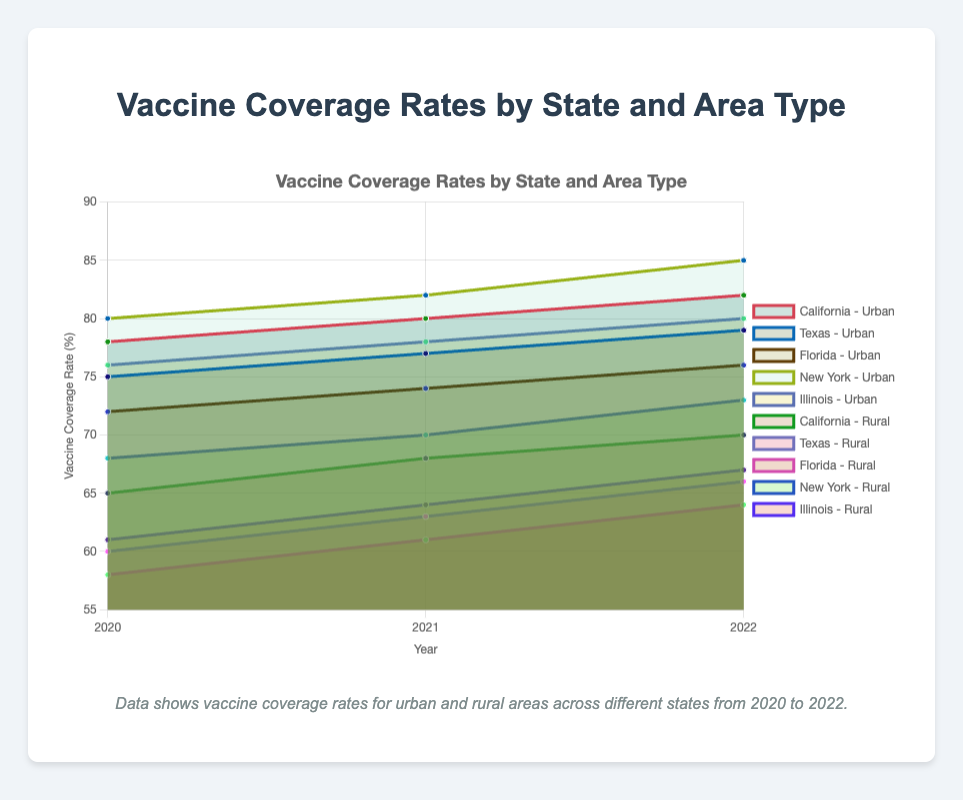What is the overall title of the chart? The title of the chart is usually prominently displayed at the top and summarizes the main topic of the chart. By looking at the top center of the chart, we can find the title "Vaccine Coverage Rates by State and Area Type".
Answer: Vaccine Coverage Rates by State and Area Type Which state had the highest urban vaccine coverage rate in 2022? To find the state with the highest urban vaccine coverage rate in 2022, look at the data points for each state in 2022 under the urban category and compare them. The state with the largest value in this category is New York with a rate of 85%.
Answer: New York How did rural vaccine coverage rates in Texas change from 2020 to 2022? Consider the specific data points for Texas under the rural category for 2020, 2021, and 2022. Rural vaccine rates in Texas were 60% in 2020, 63% in 2021, and 66% in 2022, showing a steady increase each year. Therefore, Texas saw an increase of 3 percentage points each year in rural areas.
Answer: Increased each year Which criteria can be used to classify the different sub-areas in each state in this chart? By examining the chart legend and labels, it's evident that the chart distinguishes between urban and rural areas for each state. Urban and rural categories can therefore be used as the criteria for classification.
Answer: Urban and rural What is the difference in urban vaccine coverage between New York and California in 2022? To find the difference, look at the urban coverage rates for New York and California in 2022. For New York, it is 85%, and for California, it is 82%. Subtracting California's rate from New York's rate gives 85% - 82% = 3%.
Answer: 3% Which state showed the smallest increase in urban vaccine coverage from 2020 to 2022? Look at the urban coverage rates for each state across 2020 and 2022, and calculate the increase for each. California: (82-78) = 4%, Texas: (79-75) = 4%, Florida: (76-72) = 4%, New York: (85-80) = 5%, Illinois: (80-76) = 4%. All increases are either 4% or 5%, but since the smallest increase is 4% and several states have it, an example like California shows the smallest increase.
Answer: California Is there a general trend in vaccine coverage rates between urban and rural areas? Comparing the overall vaccine rates over time for urban and rural areas visually, it is clear that urban areas consistently have higher vaccine coverage than rural areas.
Answer: Urban areas have higher rates Which state had the largest increase in rural vaccine coverage between 2020 and 2022? Calculate the rural coverage increase for each state from 2020 to 2022: California (70-65)=5%, Texas (66-60)=6%, Florida (64-58)=6%, New York (73-68)=5%, Illinois (67-61)=6%. Texas, Florida, and Illinois all had the largest increase of 6%.
Answer: Texas, Florida, or Illinois How does vaccine coverage in urban areas compare to rural areas in 2021 for Illinois? By inspecting the data points for Illinois in 2021, we see urban coverage was 78% and rural coverage was 64%. This shows urban areas had a notably higher vaccine coverage than rural areas by 14 percentage points.
Answer: 14% higher in urban areas What was the range of rural vaccine coverage rates in 2022 among all states? To determine the range, find the minimum and maximum rural vaccine coverage rates in 2022. The minimum is 64% (Florida), and the maximum is 73% (New York). Subtracting the minimum from the maximum gives 73% - 64% = 9%.
Answer: 9% 